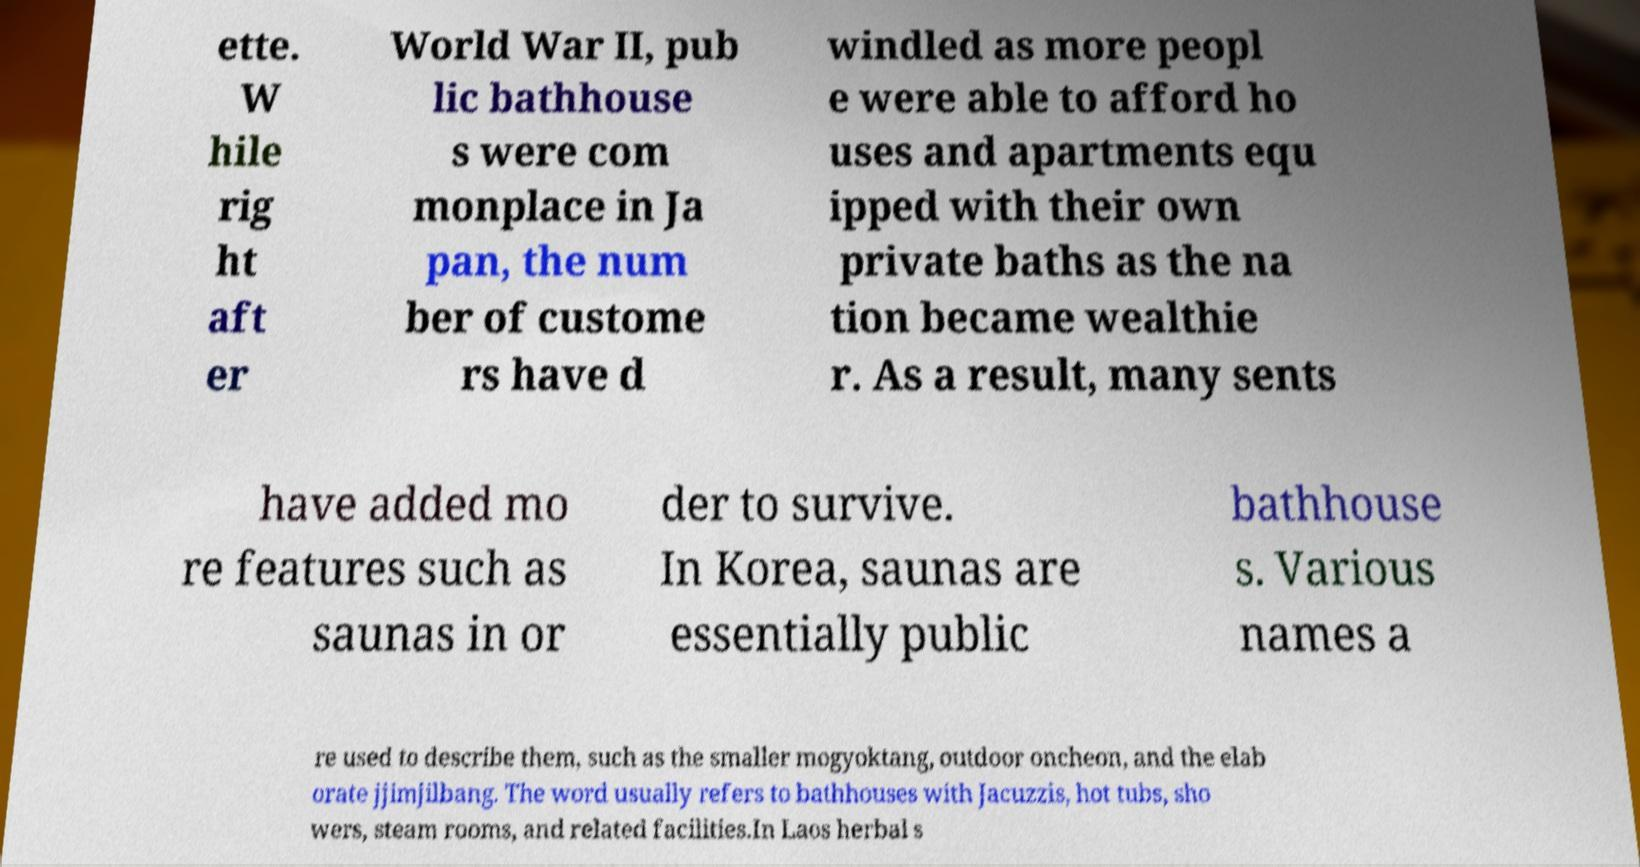Could you assist in decoding the text presented in this image and type it out clearly? ette. W hile rig ht aft er World War II, pub lic bathhouse s were com monplace in Ja pan, the num ber of custome rs have d windled as more peopl e were able to afford ho uses and apartments equ ipped with their own private baths as the na tion became wealthie r. As a result, many sents have added mo re features such as saunas in or der to survive. In Korea, saunas are essentially public bathhouse s. Various names a re used to describe them, such as the smaller mogyoktang, outdoor oncheon, and the elab orate jjimjilbang. The word usually refers to bathhouses with Jacuzzis, hot tubs, sho wers, steam rooms, and related facilities.In Laos herbal s 